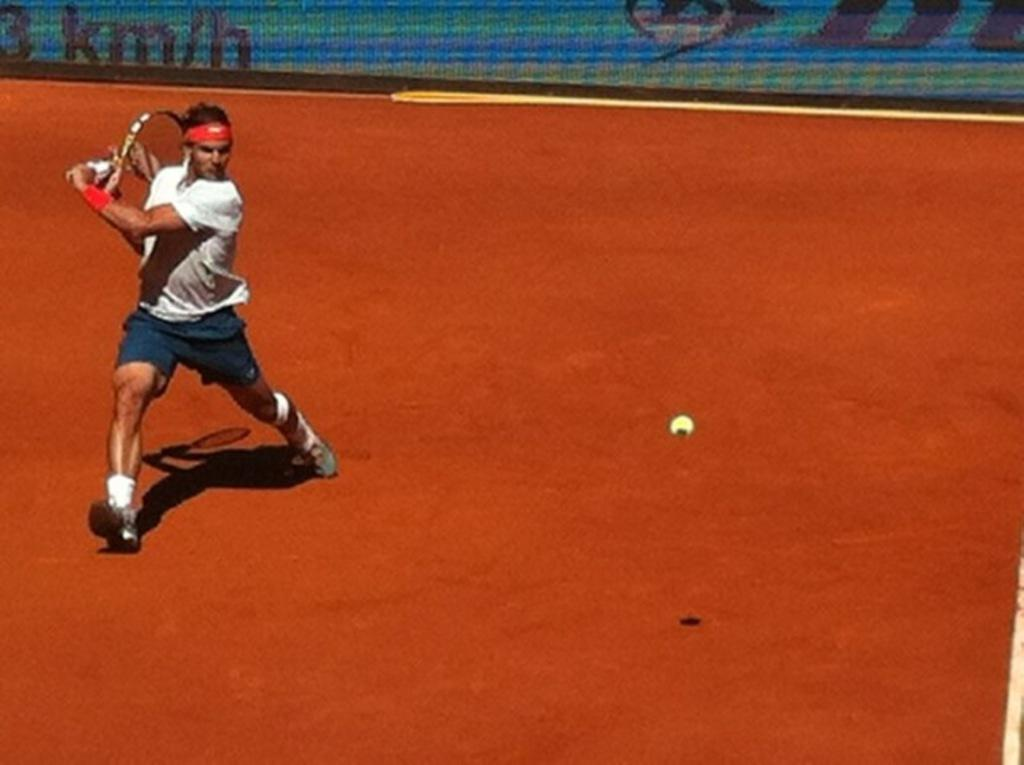Who is present in the image? There is a man in the image. What is the man holding in the image? The man is holding a tennis racket. What else can be seen in the air in the image? There is a tennis ball in the air. What can be seen in the background of the image? There is a banner in the background of the image. How many women are present in the image? There are no women present in the image; it features a man holding a tennis racket. What type of jam can be seen on the court in the image? There is no jam present in the image; it features a man holding a tennis racket and a tennis ball in the air. 